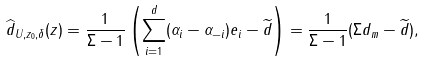<formula> <loc_0><loc_0><loc_500><loc_500>\widehat { d } _ { U , z _ { 0 } , \delta } ( z ) = \frac { 1 } { \Sigma - 1 } \left ( \sum _ { i = 1 } ^ { d } ( \alpha _ { i } - \alpha _ { - i } ) e _ { i } - \widetilde { d } \right ) = \frac { 1 } { \Sigma - 1 } ( \Sigma d _ { m } - \widetilde { d } ) ,</formula> 